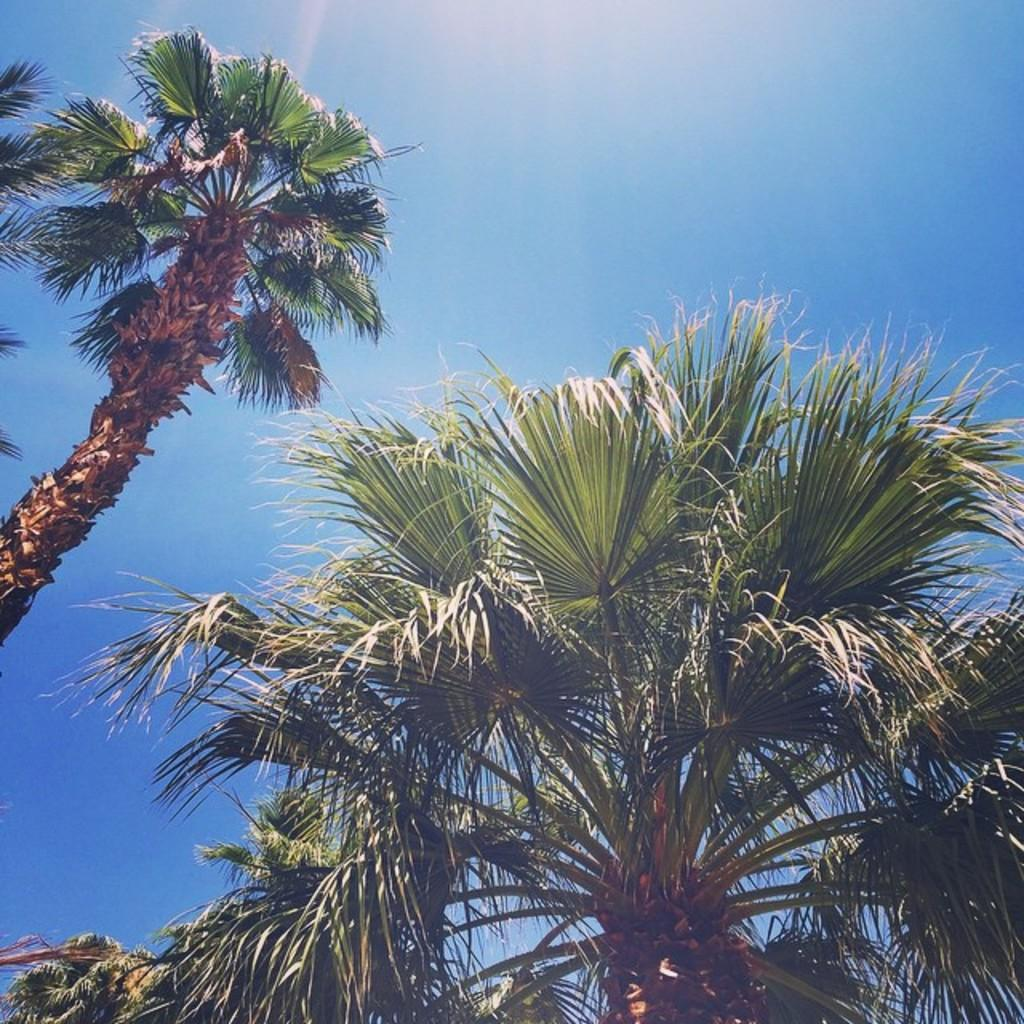What is there is a part of a tree in the image, what part of the tree can be seen? The facts do not specify which part of the tree is visible in the image. How many trees are present in the image? There are two trees in the image, one beside the other. What is visible in the background of the image? The sky is visible in the background of the image. Can you see a snail crawling on the tree in the image? There is no snail present in the image. What type of pocket is visible on the tree in the image? There is no pocket present on the tree in the image. 